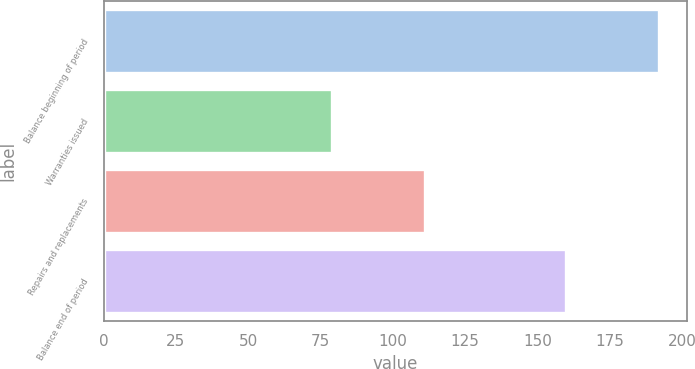Convert chart. <chart><loc_0><loc_0><loc_500><loc_500><bar_chart><fcel>Balance beginning of period<fcel>Warranties issued<fcel>Repairs and replacements<fcel>Balance end of period<nl><fcel>192<fcel>79<fcel>111<fcel>160<nl></chart> 